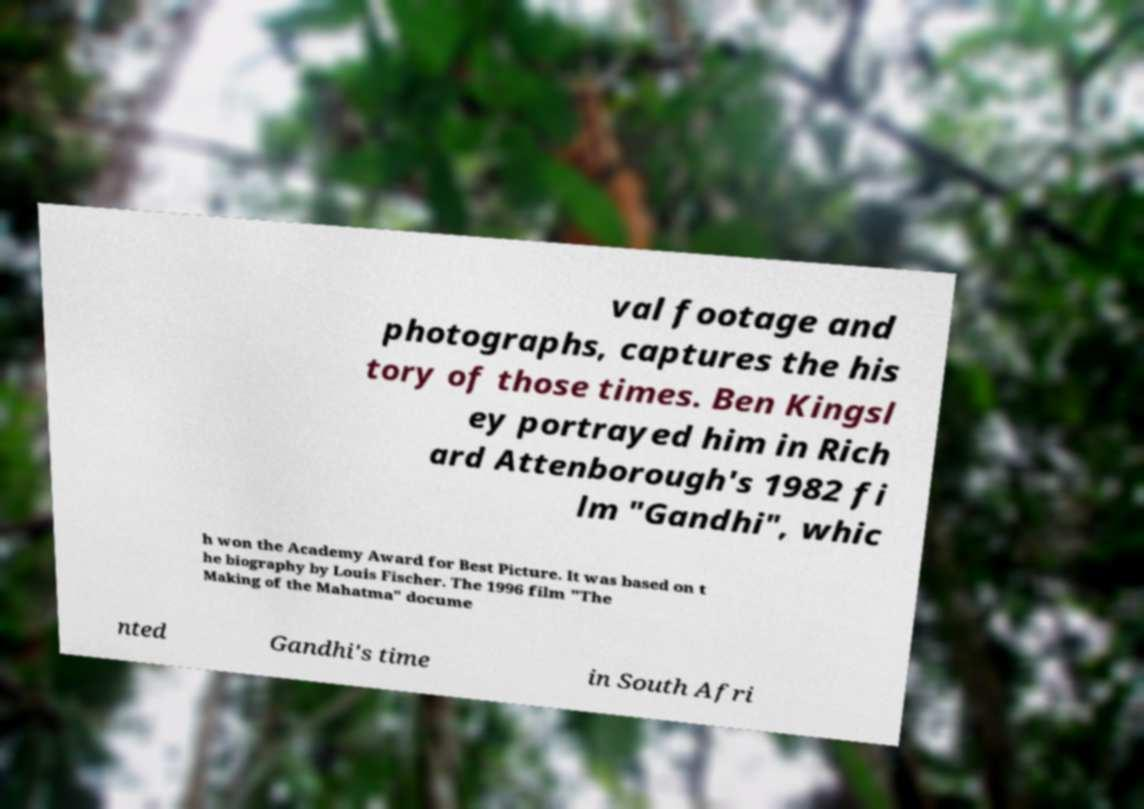Can you accurately transcribe the text from the provided image for me? val footage and photographs, captures the his tory of those times. Ben Kingsl ey portrayed him in Rich ard Attenborough's 1982 fi lm "Gandhi", whic h won the Academy Award for Best Picture. It was based on t he biography by Louis Fischer. The 1996 film "The Making of the Mahatma" docume nted Gandhi's time in South Afri 